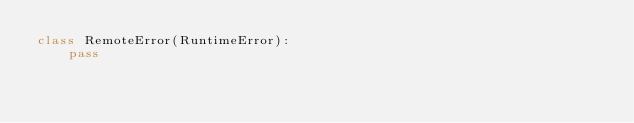Convert code to text. <code><loc_0><loc_0><loc_500><loc_500><_Python_>class RemoteError(RuntimeError):
    pass</code> 